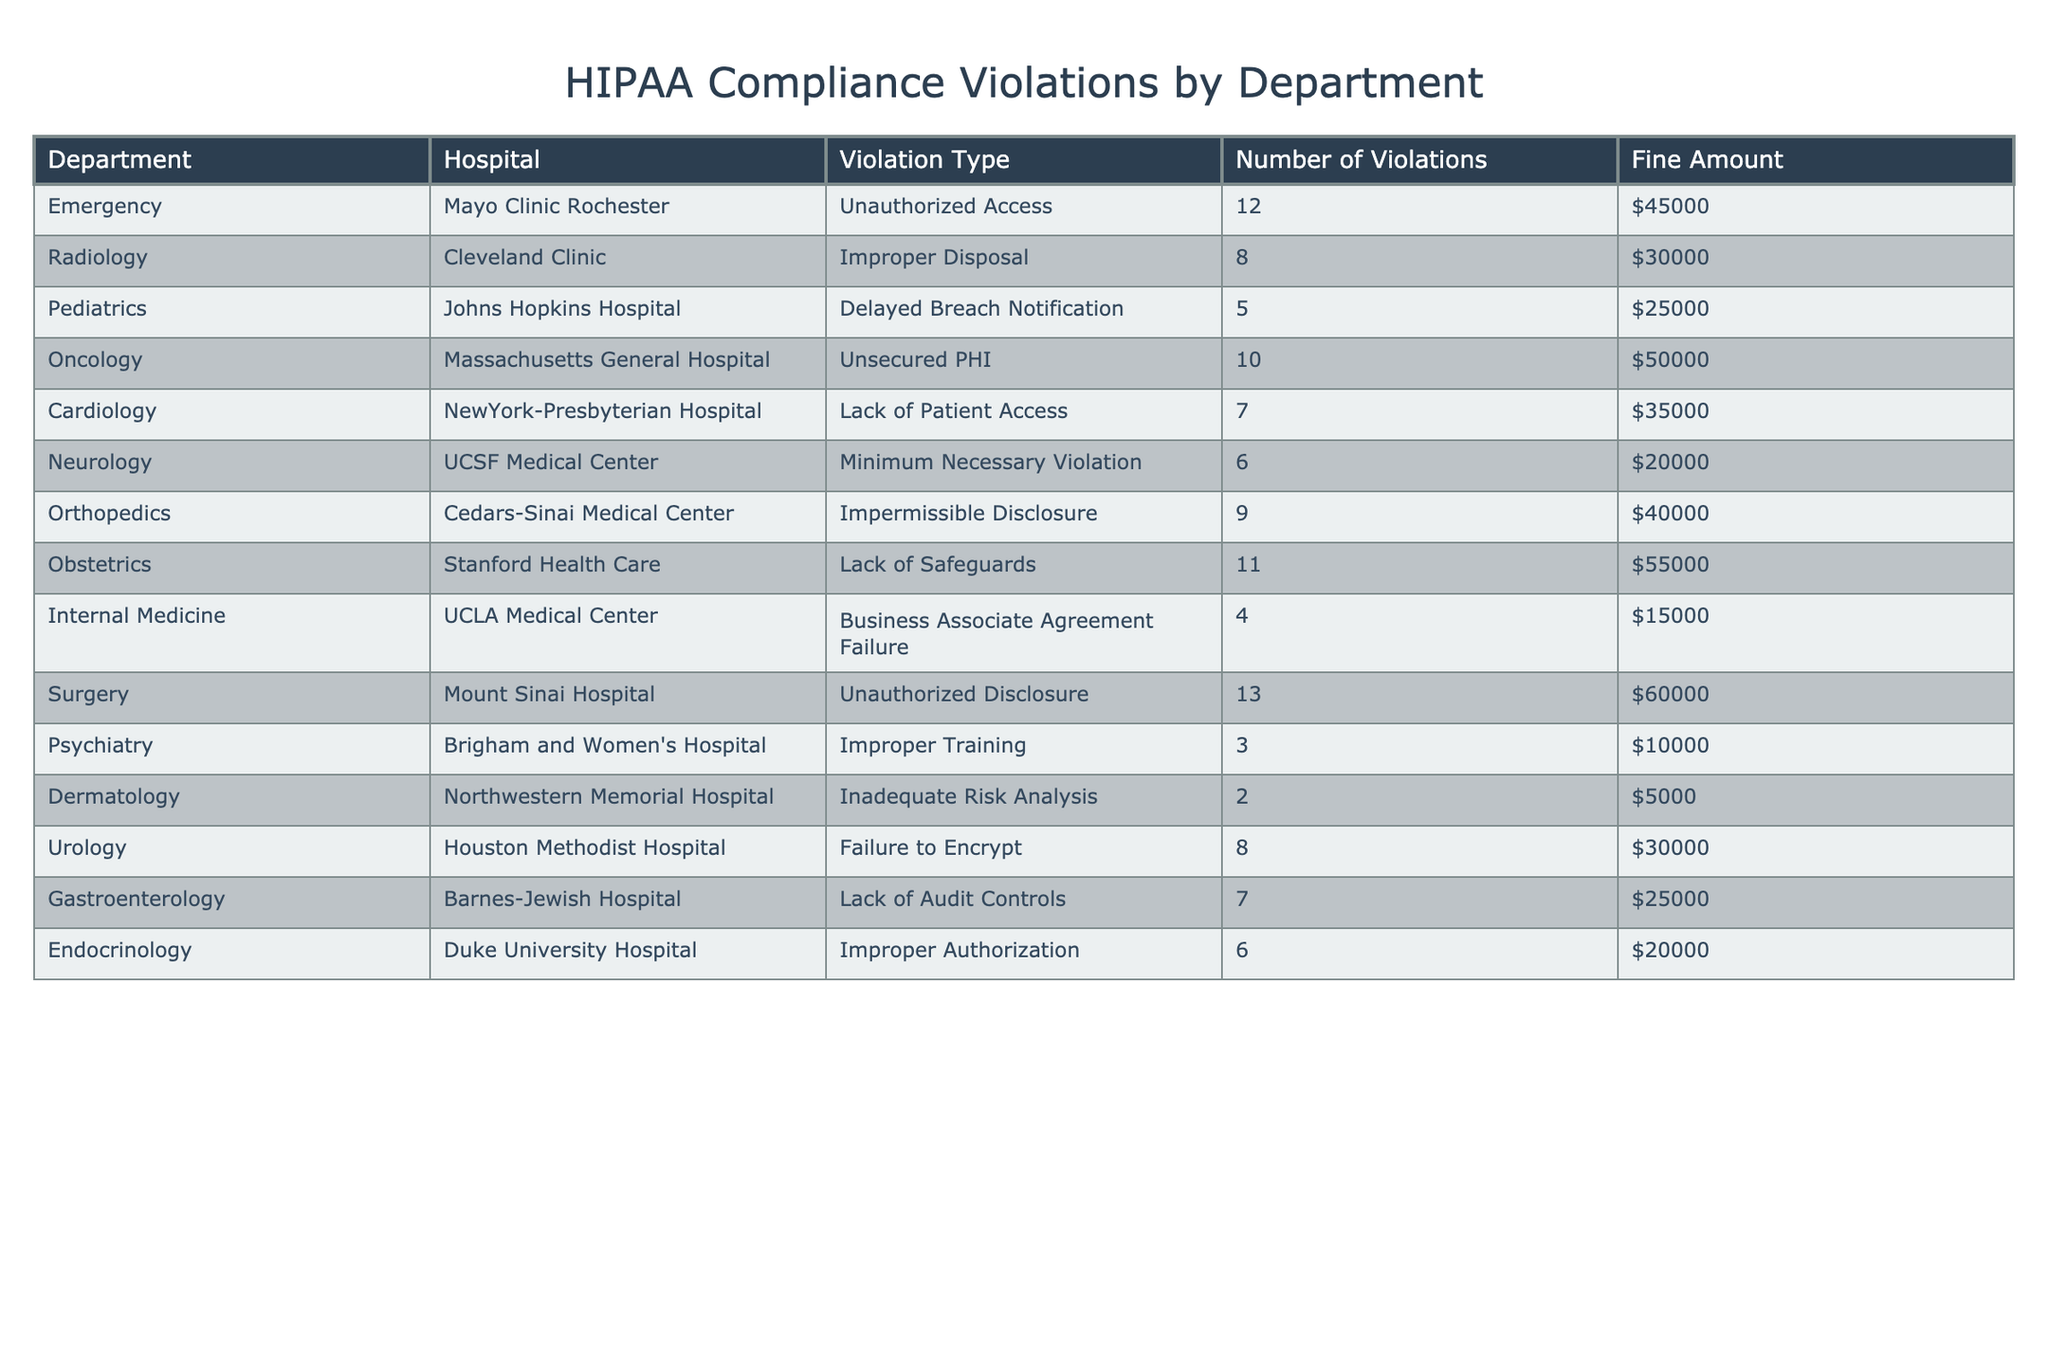What is the total number of HIPAA violations across all departments? To find the total number of HIPAA violations, I will add the "Number of Violations" from each department. The numbers are 12, 8, 5, 10, 7, 6, 9, 11, 4, 13, 3, 2, 8, and 6, which sum up to 12 + 8 + 5 + 10 + 7 + 6 + 9 + 11 + 4 + 13 + 3 + 2 + 8 + 6 =  99.
Answer: 99 Which department had the highest fine amount? The maximum fine amount in the table is found by comparing each department's "Fine Amount." The values are $45000, $30000, $25000, $50000, $35000, $20000, $40000, $55000, $15000, $60000, $10000, $5000, $30000, and $20000. The highest value is $60000, which corresponds to the Surgery department.
Answer: Surgery How many violations were there in the Radiology department? The "Number of Violations" for the Radiology department is explicitly listed in the table. It states that there were 8 violations in Radiology.
Answer: 8 What is the average fine amount per violation across all departments? First, I calculate the total fine amount by summing $45000, $30000, $25000, $50000, $35000, $20000, $40000, $55000, $15000, $60000, $10000, $5000, $30000, and $20000, which equals $319000. The total number of violations is 99. To find the average fine amount per violation, I divide 319000 by 99, which is approximately $3222.22.
Answer: $3222.22 Is there a department that reported fewer than 5 violations? I check each department's "Number of Violations" to see if any are less than 5. The departments and their violation numbers are: Emergency (12), Radiology (8), Pediatrics (5), Oncology (10), Cardiology (7), Neurology (6), Orthopedics (9), Obstetrics (11), Internal Medicine (4), Surgery (13), Psychiatry (3), Dermatology (2), Urology (8), Gastroenterology (7), and Endocrinology (6). Pediatrics, Internal Medicine, Psychiatry, and Dermatology reported fewer than 5. Yes, there are departments with fewer than 5 violations.
Answer: Yes Which hospital had the highest number of HIPAA violations and how many did it have? I need to check the "Number of Violations" for each hospital. The highest number corresponds to Surgery at Mount Sinai Hospital with 13 violations, as compared to other departments and hospitals where the counts are lower.
Answer: Mount Sinai Hospital, 13 What is the total fine amount for the Obstetrics and Surgery departments combined? I will add the "Fine Amount" for the Obstetrics department ($55000) and the Surgery department ($60000) together. So the total fine amount is $55000 + $60000 = $115000.
Answer: $115000 Which violation type is the most common, if any? I will count the occurrences of each violation type in the table: Unauthorized Access (12), Improper Disposal (8), Delayed Breach Notification (5), Unsecured PHI (10), Lack of Patient Access (7), Minimum Necessary Violation (6), Impermissible Disclosure (9), Lack of Safeguards (11), Business Associate Agreement Failure (4), Unauthorized Disclosure (13), Improper Training (3), Inadequate Risk Analysis (2), Failure to Encrypt (8), and Improper Authorization (6). Unauthorized Disclosure has the highest count at 13, making it the most common.
Answer: Unauthorized Disclosure Which department has a fine amount less than $20000 and how many violations did it incur? I check the "Fine Amount" for each department to find those under $20000. Both Psychiatry ($10000) and Dermatology ($5000) have fines below $20000. Psychiatry incurred 3 violations, and Dermatology had 2.
Answer: Psychiatry, 3; Dermatology, 2 What is the total number of violations for departments with fines greater than $40000? I identify departments with fine amounts over $40000: Oncology (10), Obstetrics (11), Surgery (13). I add their violations: 10 + 11 + 13 = 34 total violations.
Answer: 34 